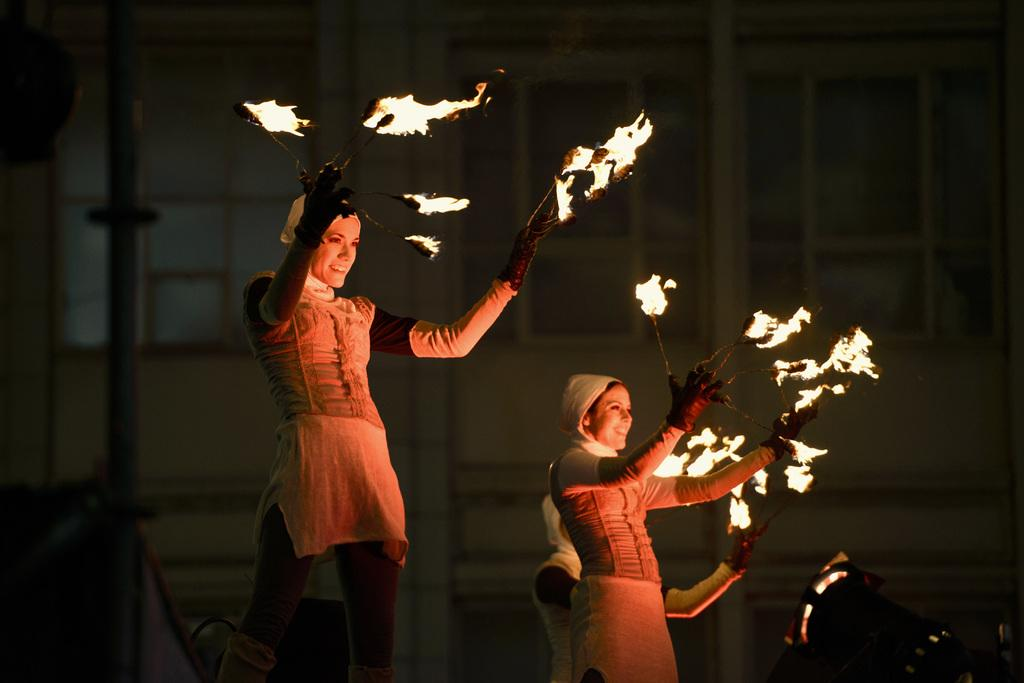What is happening in the middle of the image? There are people standing in the middle of the image. What are the people holding in their hands? The people are holding fire sticks. What can be seen in the distance behind the people? There is a building visible in the background. How does the pollution affect the friends in the image? There is no mention of friends or pollution in the image, so we cannot answer this question. 